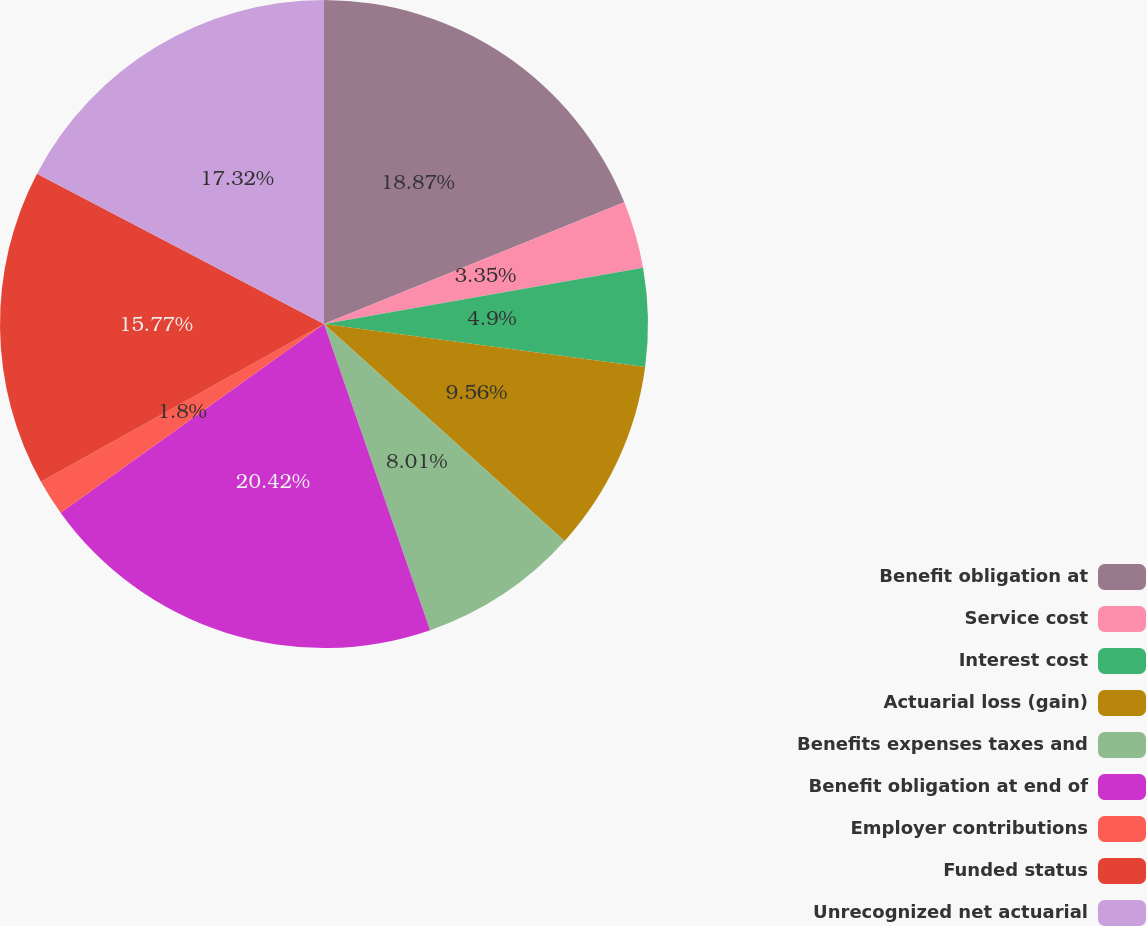Convert chart to OTSL. <chart><loc_0><loc_0><loc_500><loc_500><pie_chart><fcel>Benefit obligation at<fcel>Service cost<fcel>Interest cost<fcel>Actuarial loss (gain)<fcel>Benefits expenses taxes and<fcel>Benefit obligation at end of<fcel>Employer contributions<fcel>Funded status<fcel>Unrecognized net actuarial<nl><fcel>18.87%<fcel>3.35%<fcel>4.9%<fcel>9.56%<fcel>8.01%<fcel>20.42%<fcel>1.8%<fcel>15.77%<fcel>17.32%<nl></chart> 